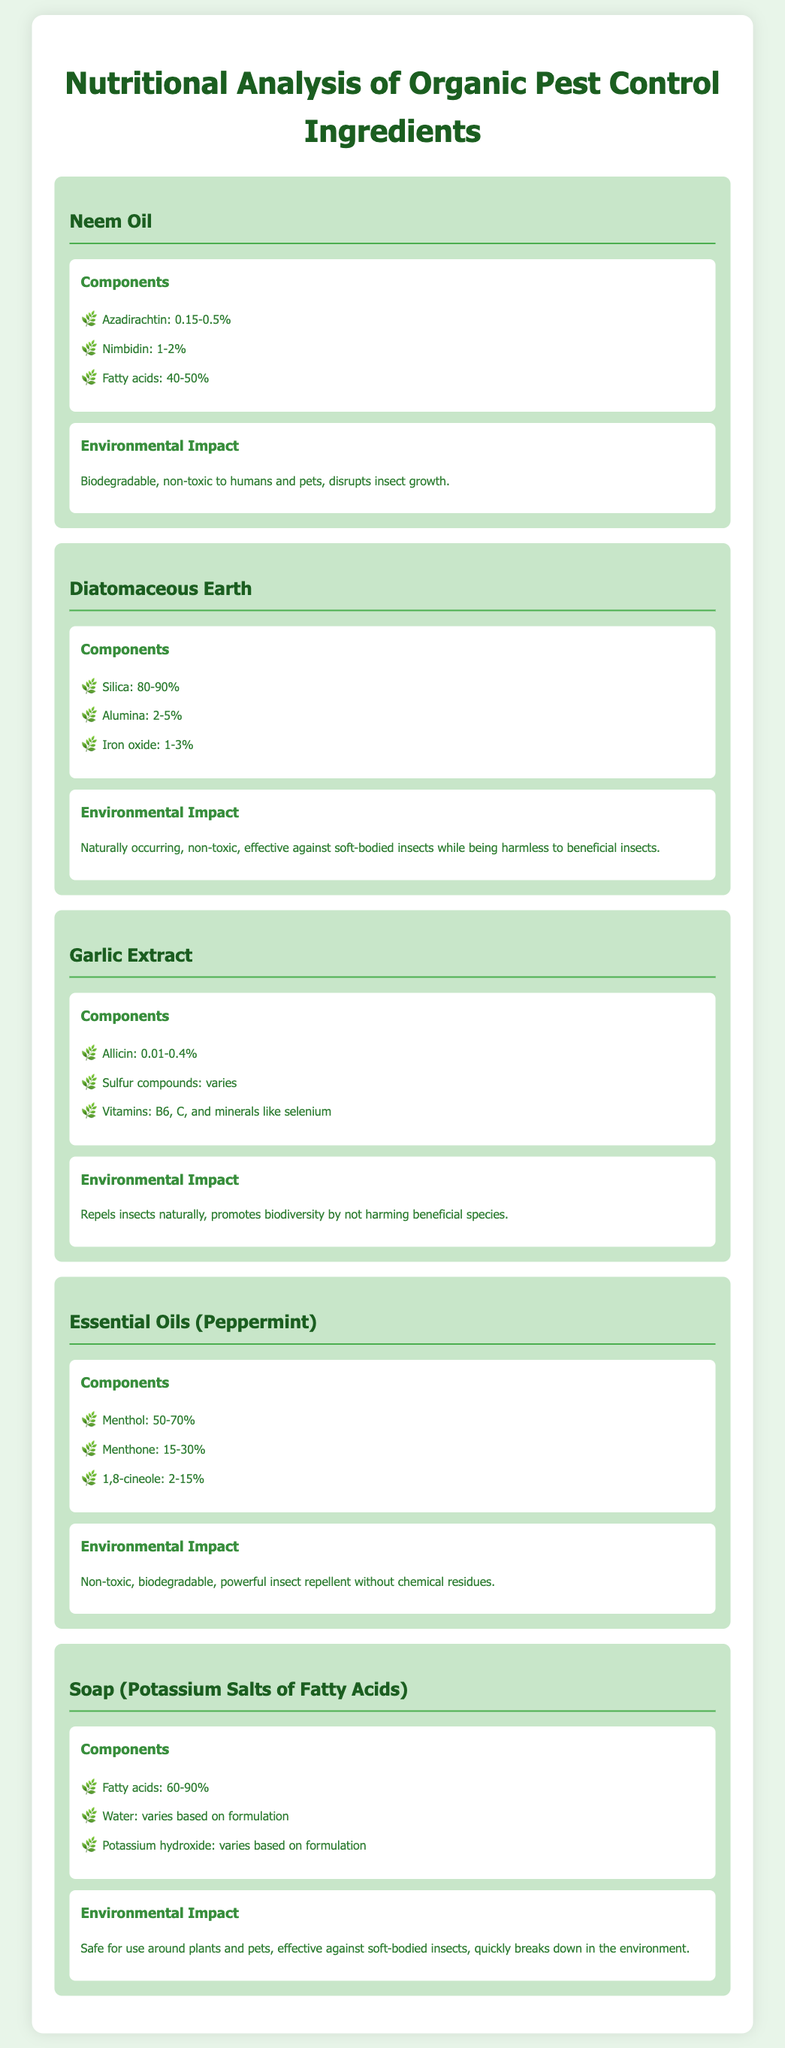what is the first ingredient listed in the catalog? The first ingredient listed is Neem Oil.
Answer: Neem Oil how much Azadirachtin is present in Neem Oil? The document states that Azadirachtin is present at 0.15-0.5%.
Answer: 0.15-0.5% what percentage of Silica is in Diatomaceous Earth? Diatomaceous Earth contains 80-90% Silica.
Answer: 80-90% which ingredient contains Allicin as a component? Allicin is a component of Garlic Extract.
Answer: Garlic Extract what is the environmental impact of Essential Oils (Peppermint)? Essential Oils (Peppermint) are described as non-toxic, biodegradable, and a powerful insect repellent without chemical residues.
Answer: Non-toxic, biodegradable, powerful insect repellent how many components are listed for the ingredient Soap (Potassium Salts of Fatty Acids)? The ingredient Soap lists three components: Fatty acids, Water, and Potassium hydroxide.
Answer: Three components which ingredient is effective against soft-bodied insects but harmless to beneficial insects? Diatomaceous Earth is effective against soft-bodied insects while being harmless to beneficial insects.
Answer: Diatomaceous Earth what is the range of Menthol in Essential Oils (Peppermint)? Menthol in Essential Oils (Peppermint) is present in the range of 50-70%.
Answer: 50-70% what do the fatty acids in Soap (Potassium Salts of Fatty Acids) range from? The fatty acids in Soap range from 60-90%.
Answer: 60-90% which organic pest control ingredient promotes biodiversity? Garlic Extract promotes biodiversity by not harming beneficial species.
Answer: Garlic Extract 